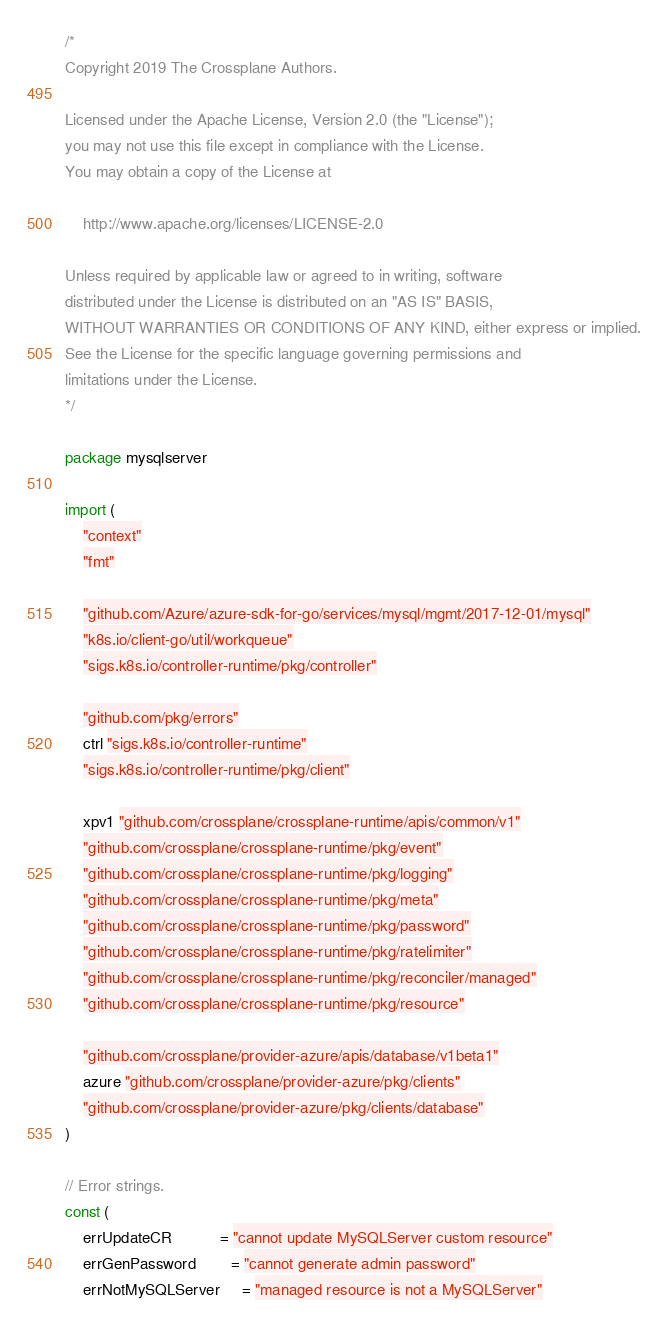<code> <loc_0><loc_0><loc_500><loc_500><_Go_>/*
Copyright 2019 The Crossplane Authors.

Licensed under the Apache License, Version 2.0 (the "License");
you may not use this file except in compliance with the License.
You may obtain a copy of the License at

    http://www.apache.org/licenses/LICENSE-2.0

Unless required by applicable law or agreed to in writing, software
distributed under the License is distributed on an "AS IS" BASIS,
WITHOUT WARRANTIES OR CONDITIONS OF ANY KIND, either express or implied.
See the License for the specific language governing permissions and
limitations under the License.
*/

package mysqlserver

import (
	"context"
	"fmt"

	"github.com/Azure/azure-sdk-for-go/services/mysql/mgmt/2017-12-01/mysql"
	"k8s.io/client-go/util/workqueue"
	"sigs.k8s.io/controller-runtime/pkg/controller"

	"github.com/pkg/errors"
	ctrl "sigs.k8s.io/controller-runtime"
	"sigs.k8s.io/controller-runtime/pkg/client"

	xpv1 "github.com/crossplane/crossplane-runtime/apis/common/v1"
	"github.com/crossplane/crossplane-runtime/pkg/event"
	"github.com/crossplane/crossplane-runtime/pkg/logging"
	"github.com/crossplane/crossplane-runtime/pkg/meta"
	"github.com/crossplane/crossplane-runtime/pkg/password"
	"github.com/crossplane/crossplane-runtime/pkg/ratelimiter"
	"github.com/crossplane/crossplane-runtime/pkg/reconciler/managed"
	"github.com/crossplane/crossplane-runtime/pkg/resource"

	"github.com/crossplane/provider-azure/apis/database/v1beta1"
	azure "github.com/crossplane/provider-azure/pkg/clients"
	"github.com/crossplane/provider-azure/pkg/clients/database"
)

// Error strings.
const (
	errUpdateCR           = "cannot update MySQLServer custom resource"
	errGenPassword        = "cannot generate admin password"
	errNotMySQLServer     = "managed resource is not a MySQLServer"</code> 